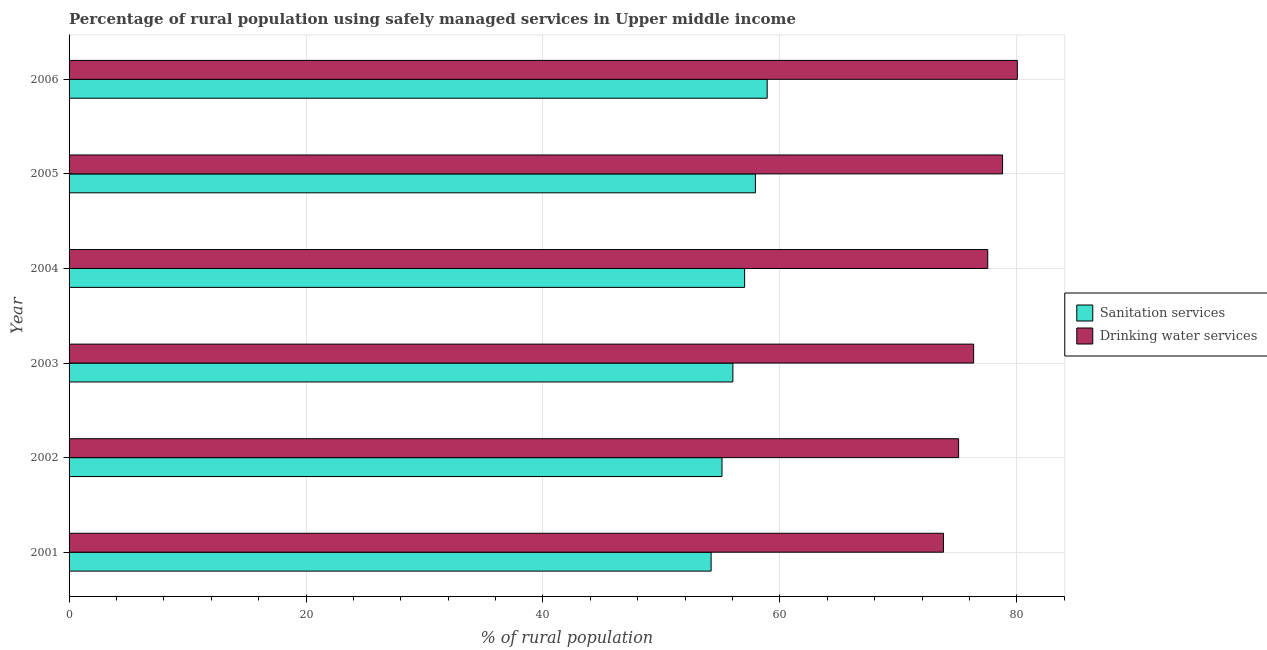Are the number of bars per tick equal to the number of legend labels?
Your answer should be very brief. Yes. Are the number of bars on each tick of the Y-axis equal?
Keep it short and to the point. Yes. How many bars are there on the 2nd tick from the top?
Keep it short and to the point. 2. In how many cases, is the number of bars for a given year not equal to the number of legend labels?
Keep it short and to the point. 0. What is the percentage of rural population who used drinking water services in 2004?
Keep it short and to the point. 77.55. Across all years, what is the maximum percentage of rural population who used sanitation services?
Give a very brief answer. 58.93. Across all years, what is the minimum percentage of rural population who used sanitation services?
Your answer should be compact. 54.2. What is the total percentage of rural population who used drinking water services in the graph?
Provide a succinct answer. 461.65. What is the difference between the percentage of rural population who used sanitation services in 2005 and that in 2006?
Your answer should be very brief. -0.99. What is the difference between the percentage of rural population who used drinking water services in 2004 and the percentage of rural population who used sanitation services in 2006?
Keep it short and to the point. 18.62. What is the average percentage of rural population who used drinking water services per year?
Your response must be concise. 76.94. In the year 2004, what is the difference between the percentage of rural population who used drinking water services and percentage of rural population who used sanitation services?
Ensure brevity in your answer.  20.52. What is the ratio of the percentage of rural population who used drinking water services in 2002 to that in 2004?
Your answer should be very brief. 0.97. Is the percentage of rural population who used drinking water services in 2005 less than that in 2006?
Offer a terse response. Yes. What is the difference between the highest and the lowest percentage of rural population who used sanitation services?
Provide a succinct answer. 4.73. In how many years, is the percentage of rural population who used drinking water services greater than the average percentage of rural population who used drinking water services taken over all years?
Keep it short and to the point. 3. What does the 2nd bar from the top in 2004 represents?
Offer a very short reply. Sanitation services. What does the 1st bar from the bottom in 2002 represents?
Make the answer very short. Sanitation services. How many years are there in the graph?
Your answer should be compact. 6. What is the difference between two consecutive major ticks on the X-axis?
Make the answer very short. 20. Does the graph contain any zero values?
Provide a succinct answer. No. How many legend labels are there?
Offer a terse response. 2. How are the legend labels stacked?
Give a very brief answer. Vertical. What is the title of the graph?
Offer a terse response. Percentage of rural population using safely managed services in Upper middle income. What is the label or title of the X-axis?
Your answer should be compact. % of rural population. What is the % of rural population of Sanitation services in 2001?
Provide a succinct answer. 54.2. What is the % of rural population of Drinking water services in 2001?
Ensure brevity in your answer.  73.81. What is the % of rural population in Sanitation services in 2002?
Your response must be concise. 55.12. What is the % of rural population in Drinking water services in 2002?
Offer a very short reply. 75.09. What is the % of rural population in Sanitation services in 2003?
Offer a terse response. 56.03. What is the % of rural population in Drinking water services in 2003?
Your answer should be compact. 76.36. What is the % of rural population in Sanitation services in 2004?
Offer a terse response. 57.02. What is the % of rural population of Drinking water services in 2004?
Provide a succinct answer. 77.55. What is the % of rural population in Sanitation services in 2005?
Keep it short and to the point. 57.94. What is the % of rural population in Drinking water services in 2005?
Provide a short and direct response. 78.8. What is the % of rural population of Sanitation services in 2006?
Ensure brevity in your answer.  58.93. What is the % of rural population in Drinking water services in 2006?
Give a very brief answer. 80.05. Across all years, what is the maximum % of rural population in Sanitation services?
Your answer should be compact. 58.93. Across all years, what is the maximum % of rural population in Drinking water services?
Offer a terse response. 80.05. Across all years, what is the minimum % of rural population of Sanitation services?
Offer a very short reply. 54.2. Across all years, what is the minimum % of rural population of Drinking water services?
Provide a succinct answer. 73.81. What is the total % of rural population in Sanitation services in the graph?
Offer a very short reply. 339.24. What is the total % of rural population of Drinking water services in the graph?
Offer a very short reply. 461.65. What is the difference between the % of rural population in Sanitation services in 2001 and that in 2002?
Ensure brevity in your answer.  -0.92. What is the difference between the % of rural population of Drinking water services in 2001 and that in 2002?
Your answer should be compact. -1.28. What is the difference between the % of rural population in Sanitation services in 2001 and that in 2003?
Your response must be concise. -1.84. What is the difference between the % of rural population of Drinking water services in 2001 and that in 2003?
Offer a terse response. -2.55. What is the difference between the % of rural population in Sanitation services in 2001 and that in 2004?
Keep it short and to the point. -2.83. What is the difference between the % of rural population of Drinking water services in 2001 and that in 2004?
Your response must be concise. -3.74. What is the difference between the % of rural population of Sanitation services in 2001 and that in 2005?
Your answer should be very brief. -3.74. What is the difference between the % of rural population in Drinking water services in 2001 and that in 2005?
Offer a very short reply. -4.99. What is the difference between the % of rural population of Sanitation services in 2001 and that in 2006?
Offer a very short reply. -4.73. What is the difference between the % of rural population of Drinking water services in 2001 and that in 2006?
Offer a very short reply. -6.24. What is the difference between the % of rural population in Sanitation services in 2002 and that in 2003?
Your response must be concise. -0.92. What is the difference between the % of rural population of Drinking water services in 2002 and that in 2003?
Your response must be concise. -1.27. What is the difference between the % of rural population of Sanitation services in 2002 and that in 2004?
Your answer should be compact. -1.91. What is the difference between the % of rural population in Drinking water services in 2002 and that in 2004?
Make the answer very short. -2.46. What is the difference between the % of rural population in Sanitation services in 2002 and that in 2005?
Provide a succinct answer. -2.82. What is the difference between the % of rural population of Drinking water services in 2002 and that in 2005?
Make the answer very short. -3.71. What is the difference between the % of rural population of Sanitation services in 2002 and that in 2006?
Provide a short and direct response. -3.81. What is the difference between the % of rural population of Drinking water services in 2002 and that in 2006?
Give a very brief answer. -4.96. What is the difference between the % of rural population in Sanitation services in 2003 and that in 2004?
Keep it short and to the point. -0.99. What is the difference between the % of rural population in Drinking water services in 2003 and that in 2004?
Keep it short and to the point. -1.19. What is the difference between the % of rural population of Sanitation services in 2003 and that in 2005?
Your answer should be compact. -1.9. What is the difference between the % of rural population of Drinking water services in 2003 and that in 2005?
Offer a terse response. -2.44. What is the difference between the % of rural population in Sanitation services in 2003 and that in 2006?
Your answer should be very brief. -2.89. What is the difference between the % of rural population of Drinking water services in 2003 and that in 2006?
Make the answer very short. -3.69. What is the difference between the % of rural population of Sanitation services in 2004 and that in 2005?
Make the answer very short. -0.91. What is the difference between the % of rural population of Drinking water services in 2004 and that in 2005?
Your answer should be compact. -1.25. What is the difference between the % of rural population of Sanitation services in 2004 and that in 2006?
Make the answer very short. -1.9. What is the difference between the % of rural population in Drinking water services in 2004 and that in 2006?
Your answer should be very brief. -2.5. What is the difference between the % of rural population in Sanitation services in 2005 and that in 2006?
Keep it short and to the point. -0.99. What is the difference between the % of rural population in Drinking water services in 2005 and that in 2006?
Your response must be concise. -1.25. What is the difference between the % of rural population of Sanitation services in 2001 and the % of rural population of Drinking water services in 2002?
Your answer should be compact. -20.89. What is the difference between the % of rural population of Sanitation services in 2001 and the % of rural population of Drinking water services in 2003?
Make the answer very short. -22.16. What is the difference between the % of rural population in Sanitation services in 2001 and the % of rural population in Drinking water services in 2004?
Give a very brief answer. -23.35. What is the difference between the % of rural population in Sanitation services in 2001 and the % of rural population in Drinking water services in 2005?
Provide a short and direct response. -24.6. What is the difference between the % of rural population of Sanitation services in 2001 and the % of rural population of Drinking water services in 2006?
Give a very brief answer. -25.85. What is the difference between the % of rural population in Sanitation services in 2002 and the % of rural population in Drinking water services in 2003?
Your answer should be very brief. -21.24. What is the difference between the % of rural population in Sanitation services in 2002 and the % of rural population in Drinking water services in 2004?
Your answer should be compact. -22.43. What is the difference between the % of rural population of Sanitation services in 2002 and the % of rural population of Drinking water services in 2005?
Your answer should be compact. -23.68. What is the difference between the % of rural population of Sanitation services in 2002 and the % of rural population of Drinking water services in 2006?
Keep it short and to the point. -24.93. What is the difference between the % of rural population in Sanitation services in 2003 and the % of rural population in Drinking water services in 2004?
Offer a terse response. -21.51. What is the difference between the % of rural population in Sanitation services in 2003 and the % of rural population in Drinking water services in 2005?
Offer a terse response. -22.76. What is the difference between the % of rural population in Sanitation services in 2003 and the % of rural population in Drinking water services in 2006?
Your response must be concise. -24.01. What is the difference between the % of rural population in Sanitation services in 2004 and the % of rural population in Drinking water services in 2005?
Ensure brevity in your answer.  -21.77. What is the difference between the % of rural population of Sanitation services in 2004 and the % of rural population of Drinking water services in 2006?
Offer a terse response. -23.02. What is the difference between the % of rural population of Sanitation services in 2005 and the % of rural population of Drinking water services in 2006?
Your answer should be very brief. -22.11. What is the average % of rural population in Sanitation services per year?
Give a very brief answer. 56.54. What is the average % of rural population in Drinking water services per year?
Keep it short and to the point. 76.94. In the year 2001, what is the difference between the % of rural population of Sanitation services and % of rural population of Drinking water services?
Give a very brief answer. -19.61. In the year 2002, what is the difference between the % of rural population in Sanitation services and % of rural population in Drinking water services?
Your answer should be compact. -19.97. In the year 2003, what is the difference between the % of rural population of Sanitation services and % of rural population of Drinking water services?
Make the answer very short. -20.32. In the year 2004, what is the difference between the % of rural population in Sanitation services and % of rural population in Drinking water services?
Provide a short and direct response. -20.52. In the year 2005, what is the difference between the % of rural population in Sanitation services and % of rural population in Drinking water services?
Ensure brevity in your answer.  -20.86. In the year 2006, what is the difference between the % of rural population in Sanitation services and % of rural population in Drinking water services?
Keep it short and to the point. -21.12. What is the ratio of the % of rural population of Sanitation services in 2001 to that in 2002?
Your response must be concise. 0.98. What is the ratio of the % of rural population of Sanitation services in 2001 to that in 2003?
Offer a terse response. 0.97. What is the ratio of the % of rural population in Drinking water services in 2001 to that in 2003?
Your answer should be compact. 0.97. What is the ratio of the % of rural population in Sanitation services in 2001 to that in 2004?
Provide a short and direct response. 0.95. What is the ratio of the % of rural population of Drinking water services in 2001 to that in 2004?
Make the answer very short. 0.95. What is the ratio of the % of rural population of Sanitation services in 2001 to that in 2005?
Your answer should be very brief. 0.94. What is the ratio of the % of rural population of Drinking water services in 2001 to that in 2005?
Your response must be concise. 0.94. What is the ratio of the % of rural population of Sanitation services in 2001 to that in 2006?
Your response must be concise. 0.92. What is the ratio of the % of rural population of Drinking water services in 2001 to that in 2006?
Provide a short and direct response. 0.92. What is the ratio of the % of rural population of Sanitation services in 2002 to that in 2003?
Offer a terse response. 0.98. What is the ratio of the % of rural population of Drinking water services in 2002 to that in 2003?
Give a very brief answer. 0.98. What is the ratio of the % of rural population in Sanitation services in 2002 to that in 2004?
Your answer should be compact. 0.97. What is the ratio of the % of rural population of Drinking water services in 2002 to that in 2004?
Give a very brief answer. 0.97. What is the ratio of the % of rural population in Sanitation services in 2002 to that in 2005?
Offer a very short reply. 0.95. What is the ratio of the % of rural population in Drinking water services in 2002 to that in 2005?
Offer a very short reply. 0.95. What is the ratio of the % of rural population in Sanitation services in 2002 to that in 2006?
Provide a short and direct response. 0.94. What is the ratio of the % of rural population in Drinking water services in 2002 to that in 2006?
Your answer should be compact. 0.94. What is the ratio of the % of rural population of Sanitation services in 2003 to that in 2004?
Offer a terse response. 0.98. What is the ratio of the % of rural population of Drinking water services in 2003 to that in 2004?
Ensure brevity in your answer.  0.98. What is the ratio of the % of rural population of Sanitation services in 2003 to that in 2005?
Your response must be concise. 0.97. What is the ratio of the % of rural population of Sanitation services in 2003 to that in 2006?
Your answer should be compact. 0.95. What is the ratio of the % of rural population in Drinking water services in 2003 to that in 2006?
Offer a very short reply. 0.95. What is the ratio of the % of rural population of Sanitation services in 2004 to that in 2005?
Offer a terse response. 0.98. What is the ratio of the % of rural population of Drinking water services in 2004 to that in 2005?
Ensure brevity in your answer.  0.98. What is the ratio of the % of rural population in Sanitation services in 2004 to that in 2006?
Make the answer very short. 0.97. What is the ratio of the % of rural population of Drinking water services in 2004 to that in 2006?
Offer a very short reply. 0.97. What is the ratio of the % of rural population in Sanitation services in 2005 to that in 2006?
Offer a very short reply. 0.98. What is the ratio of the % of rural population in Drinking water services in 2005 to that in 2006?
Offer a very short reply. 0.98. What is the difference between the highest and the second highest % of rural population in Sanitation services?
Keep it short and to the point. 0.99. What is the difference between the highest and the second highest % of rural population in Drinking water services?
Offer a terse response. 1.25. What is the difference between the highest and the lowest % of rural population in Sanitation services?
Offer a terse response. 4.73. What is the difference between the highest and the lowest % of rural population in Drinking water services?
Offer a terse response. 6.24. 